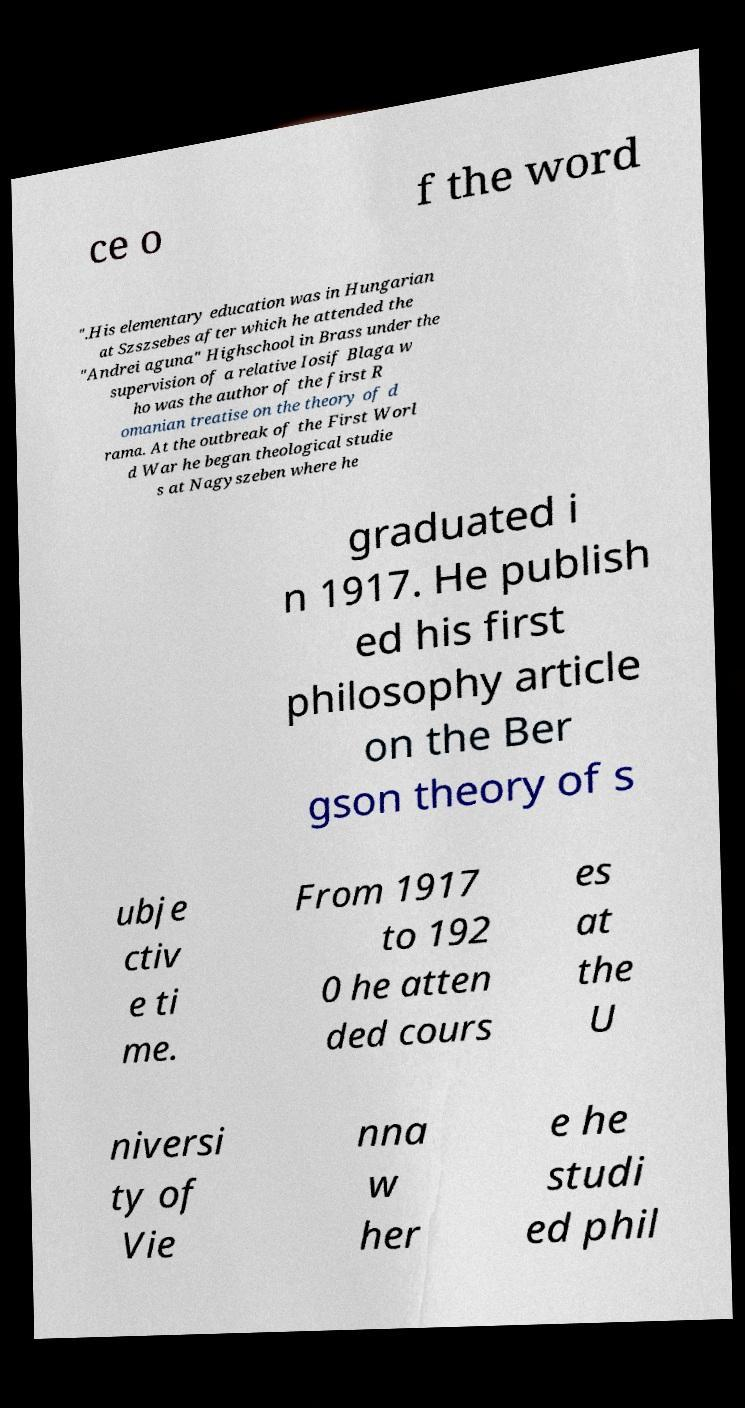For documentation purposes, I need the text within this image transcribed. Could you provide that? ce o f the word ".His elementary education was in Hungarian at Szszsebes after which he attended the "Andrei aguna" Highschool in Brass under the supervision of a relative Iosif Blaga w ho was the author of the first R omanian treatise on the theory of d rama. At the outbreak of the First Worl d War he began theological studie s at Nagyszeben where he graduated i n 1917. He publish ed his first philosophy article on the Ber gson theory of s ubje ctiv e ti me. From 1917 to 192 0 he atten ded cours es at the U niversi ty of Vie nna w her e he studi ed phil 